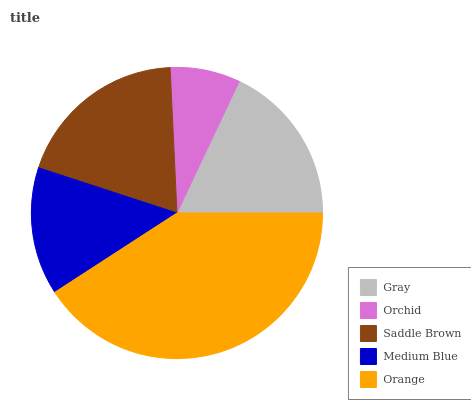Is Orchid the minimum?
Answer yes or no. Yes. Is Orange the maximum?
Answer yes or no. Yes. Is Saddle Brown the minimum?
Answer yes or no. No. Is Saddle Brown the maximum?
Answer yes or no. No. Is Saddle Brown greater than Orchid?
Answer yes or no. Yes. Is Orchid less than Saddle Brown?
Answer yes or no. Yes. Is Orchid greater than Saddle Brown?
Answer yes or no. No. Is Saddle Brown less than Orchid?
Answer yes or no. No. Is Gray the high median?
Answer yes or no. Yes. Is Gray the low median?
Answer yes or no. Yes. Is Orchid the high median?
Answer yes or no. No. Is Orchid the low median?
Answer yes or no. No. 